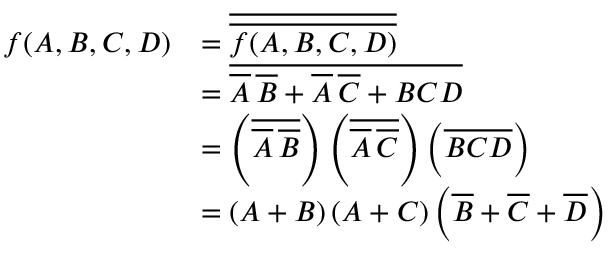<formula> <loc_0><loc_0><loc_500><loc_500>{ \begin{array} { r l } { f ( A , B , C , D ) } & { = { \overline { { \overline { f ( A , B , C , D ) } } } } } \\ & { = { \overline { { { \overline { A } } \, { \overline { B } } + { \overline { A } } \, { \overline { C } } + B C D } } } } \\ & { = \left ( { \overline { { { \overline { A } } \, { \overline { B } } } } } \right ) \left ( { \overline { { { \overline { A } } \, { \overline { C } } } } } \right ) \left ( { \overline { B C D } } \right ) } \\ & { = \left ( A + B \right ) \left ( A + C \right ) \left ( { \overline { B } } + { \overline { C } } + { \overline { D } } \right ) } \end{array} }</formula> 